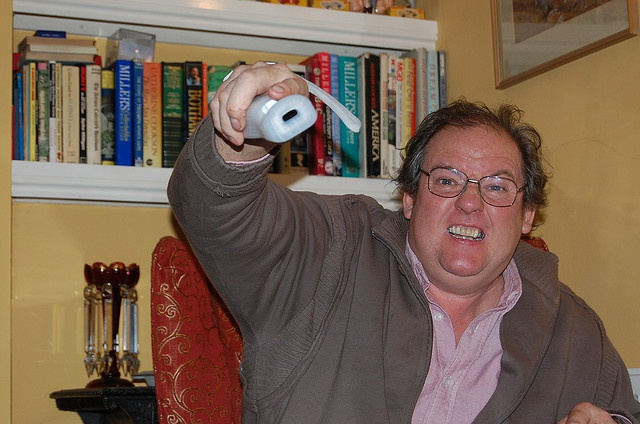Describe the objects in this image and their specific colors. I can see people in olive, gray, black, and brown tones, chair in olive, maroon, brown, and black tones, book in olive, gray, black, tan, and darkgray tones, book in olive, teal, black, and darkgray tones, and remote in olive, lightblue, darkgray, and lightgray tones in this image. 